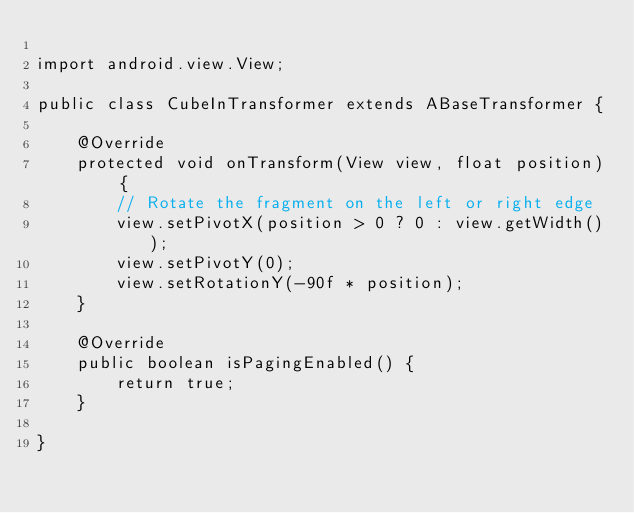<code> <loc_0><loc_0><loc_500><loc_500><_Java_>
import android.view.View;

public class CubeInTransformer extends ABaseTransformer {

	@Override
	protected void onTransform(View view, float position) {
		// Rotate the fragment on the left or right edge
		view.setPivotX(position > 0 ? 0 : view.getWidth());
		view.setPivotY(0);
		view.setRotationY(-90f * position);
	}

	@Override
	public boolean isPagingEnabled() {
		return true;
	}

}
</code> 